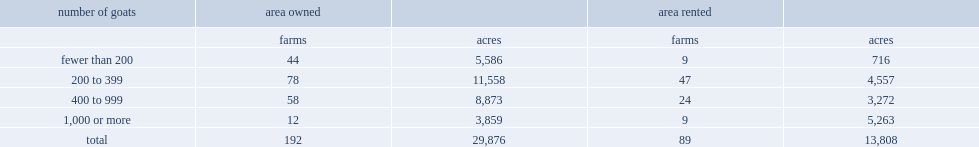For dairy goat farms with 1000 or more, which sector has more total area reported? area owned or area rented? Area rented. For those with fewer than 1000 goats, which sector has more total area reported? area owned or area rented? Area owned. Would you be able to parse every entry in this table? {'header': ['number of goats', 'area owned', '', 'area rented', ''], 'rows': [['', 'farms', 'acres', 'farms', 'acres'], ['fewer than 200', '44', '5,586', '9', '716'], ['200 to 399', '78', '11,558', '47', '4,557'], ['400 to 999', '58', '8,873', '24', '3,272'], ['1,000 or more', '12', '3,859', '9', '5,263'], ['total', '192', '29,876', '89', '13,808']]} 